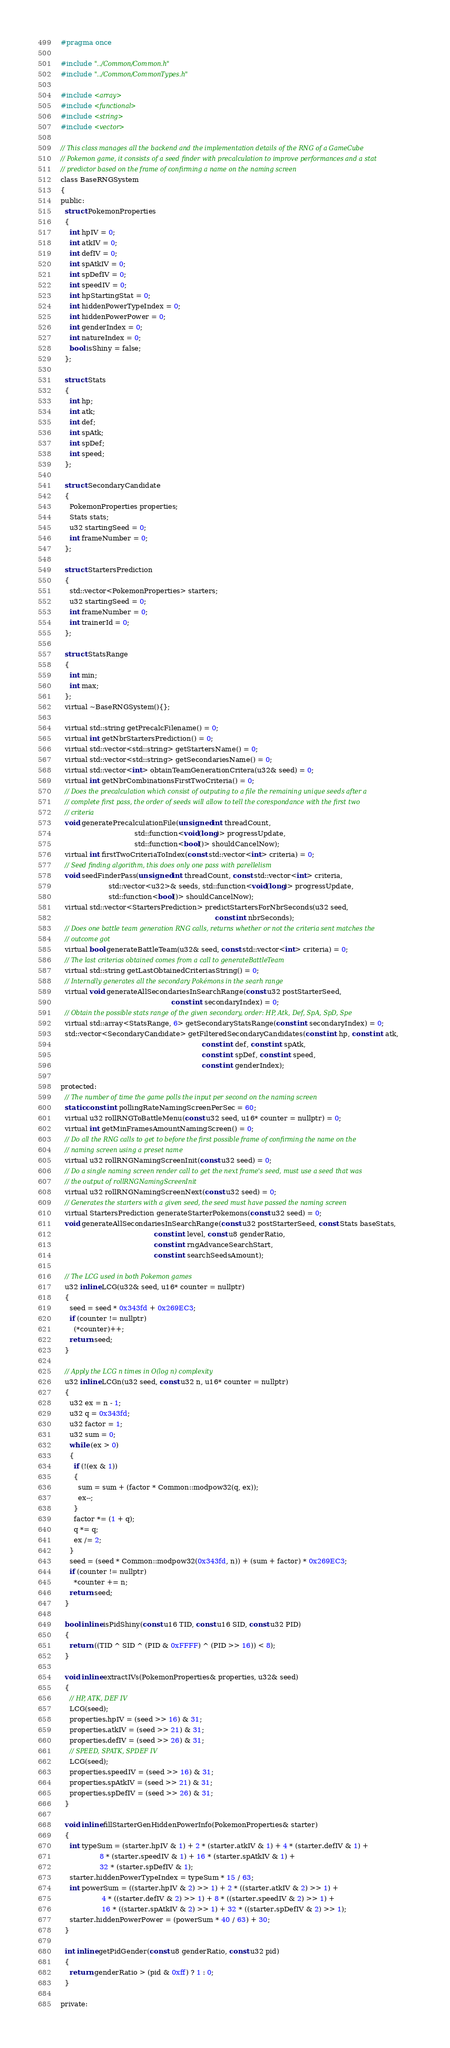Convert code to text. <code><loc_0><loc_0><loc_500><loc_500><_C_>#pragma once

#include "../Common/Common.h"
#include "../Common/CommonTypes.h"

#include <array>
#include <functional>
#include <string>
#include <vector>

// This class manages all the backend and the implementation details of the RNG of a GameCube
// Pokemon game, it consists of a seed finder with precalculation to improve performances and a stat
// predictor based on the frame of confirming a name on the naming screen
class BaseRNGSystem
{
public:
  struct PokemonProperties
  {
    int hpIV = 0;
    int atkIV = 0;
    int defIV = 0;
    int spAtkIV = 0;
    int spDefIV = 0;
    int speedIV = 0;
    int hpStartingStat = 0;
    int hiddenPowerTypeIndex = 0;
    int hiddenPowerPower = 0;
    int genderIndex = 0;
    int natureIndex = 0;
    bool isShiny = false;
  };

  struct Stats
  {
    int hp;
    int atk;
    int def;
    int spAtk;
    int spDef;
    int speed;
  };

  struct SecondaryCandidate
  {
    PokemonProperties properties;
    Stats stats;
    u32 startingSeed = 0;
    int frameNumber = 0;
  };

  struct StartersPrediction
  {
    std::vector<PokemonProperties> starters;
    u32 startingSeed = 0;
    int frameNumber = 0;
    int trainerId = 0;
  };

  struct StatsRange
  {
    int min;
    int max;
  };
  virtual ~BaseRNGSystem(){};

  virtual std::string getPrecalcFilename() = 0;
  virtual int getNbrStartersPrediction() = 0;
  virtual std::vector<std::string> getStartersName() = 0;
  virtual std::vector<std::string> getSecondariesName() = 0;
  virtual std::vector<int> obtainTeamGenerationCritera(u32& seed) = 0;
  virtual int getNbrCombinationsFirstTwoCriteria() = 0;
  // Does the precalculation which consist of outputing to a file the remaining unique seeds after a
  // complete first pass, the order of seeds will allow to tell the corespondance with the first two
  // criteria
  void generatePrecalculationFile(unsigned int threadCount,
                                  std::function<void(long)> progressUpdate,
                                  std::function<bool()> shouldCancelNow);
  virtual int firstTwoCriteriaToIndex(const std::vector<int> criteria) = 0;
  // Seed finding algorithm, this does only one pass with parellelism
  void seedFinderPass(unsigned int threadCount, const std::vector<int> criteria,
                      std::vector<u32>& seeds, std::function<void(long)> progressUpdate,
                      std::function<bool()> shouldCancelNow);
  virtual std::vector<StartersPrediction> predictStartersForNbrSeconds(u32 seed,
                                                                       const int nbrSeconds);
  // Does one battle team generation RNG calls, returns whether or not the criteria sent matches the
  // outcome got
  virtual bool generateBattleTeam(u32& seed, const std::vector<int> criteria) = 0;
  // The last criterias obtained comes from a call to generateBattleTeam
  virtual std::string getLastObtainedCriteriasString() = 0;
  // Internally generates all the secondary Pokémons in the searh range
  virtual void generateAllSecondariesInSearchRange(const u32 postStarterSeed,
                                                   const int secondaryIndex) = 0;
  // Obtain the possible stats range of the given secondary, order: HP, Atk, Def, SpA, SpD, Spe
  virtual std::array<StatsRange, 6> getSecondaryStatsRange(const int secondaryIndex) = 0;
  std::vector<SecondaryCandidate> getFilteredSecondaryCandidates(const int hp, const int atk,
                                                                 const int def, const int spAtk,
                                                                 const int spDef, const int speed,
                                                                 const int genderIndex);

protected:
  // The number of time the game polls the input per second on the naming screen
  static const int pollingRateNamingScreenPerSec = 60;
  virtual u32 rollRNGToBattleMenu(const u32 seed, u16* counter = nullptr) = 0;
  virtual int getMinFramesAmountNamingScreen() = 0;
  // Do all the RNG calls to get to before the first possible frame of confirming the name on the
  // naming screen using a preset name
  virtual u32 rollRNGNamingScreenInit(const u32 seed) = 0;
  // Do a single naming screen render call to get the next frame's seed, must use a seed that was
  // the output of rollRNGNamingScreenInit
  virtual u32 rollRNGNamingScreenNext(const u32 seed) = 0;
  // Generates the starters with a given seed, the seed must have passed the naming screen
  virtual StartersPrediction generateStarterPokemons(const u32 seed) = 0;
  void generateAllSecondariesInSearchRange(const u32 postStarterSeed, const Stats baseStats,
                                           const int level, const u8 genderRatio,
                                           const int rngAdvanceSearchStart,
                                           const int searchSeedsAmount);

  // The LCG used in both Pokemon games
  u32 inline LCG(u32& seed, u16* counter = nullptr)
  {
    seed = seed * 0x343fd + 0x269EC3;
    if (counter != nullptr)
      (*counter)++;
    return seed;
  }

  // Apply the LCG n times in O(log n) complexity
  u32 inline LCGn(u32 seed, const u32 n, u16* counter = nullptr)
  {
    u32 ex = n - 1;
    u32 q = 0x343fd;
    u32 factor = 1;
    u32 sum = 0;
    while (ex > 0)
    {
      if (!(ex & 1))
      {
        sum = sum + (factor * Common::modpow32(q, ex));
        ex--;
      }
      factor *= (1 + q);
      q *= q;
      ex /= 2;
    }
    seed = (seed * Common::modpow32(0x343fd, n)) + (sum + factor) * 0x269EC3;
    if (counter != nullptr)
      *counter += n;
    return seed;
  }

  bool inline isPidShiny(const u16 TID, const u16 SID, const u32 PID)
  {
    return ((TID ^ SID ^ (PID & 0xFFFF) ^ (PID >> 16)) < 8);
  }

  void inline extractIVs(PokemonProperties& properties, u32& seed)
  {
    // HP, ATK, DEF IV
    LCG(seed);
    properties.hpIV = (seed >> 16) & 31;
    properties.atkIV = (seed >> 21) & 31;
    properties.defIV = (seed >> 26) & 31;
    // SPEED, SPATK, SPDEF IV
    LCG(seed);
    properties.speedIV = (seed >> 16) & 31;
    properties.spAtkIV = (seed >> 21) & 31;
    properties.spDefIV = (seed >> 26) & 31;
  }

  void inline fillStarterGenHiddenPowerInfo(PokemonProperties& starter)
  {
    int typeSum = (starter.hpIV & 1) + 2 * (starter.atkIV & 1) + 4 * (starter.defIV & 1) +
                  8 * (starter.speedIV & 1) + 16 * (starter.spAtkIV & 1) +
                  32 * (starter.spDefIV & 1);
    starter.hiddenPowerTypeIndex = typeSum * 15 / 63;
    int powerSum = ((starter.hpIV & 2) >> 1) + 2 * ((starter.atkIV & 2) >> 1) +
                   4 * ((starter.defIV & 2) >> 1) + 8 * ((starter.speedIV & 2) >> 1) +
                   16 * ((starter.spAtkIV & 2) >> 1) + 32 * ((starter.spDefIV & 2) >> 1);
    starter.hiddenPowerPower = (powerSum * 40 / 63) + 30;
  }

  int inline getPidGender(const u8 genderRatio, const u32 pid)
  {
    return genderRatio > (pid & 0xff) ? 1 : 0;
  }

private:</code> 